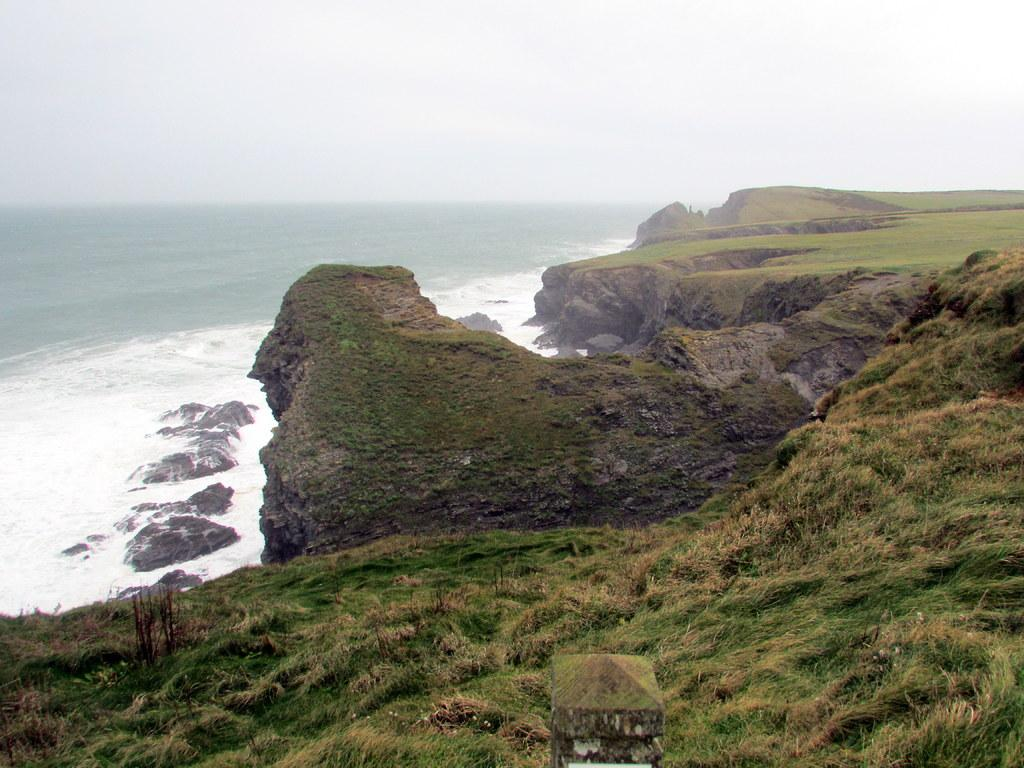What is the primary element visible in the image? There is water in the image. What other objects or features can be seen in the image? There are rocks and plants on the ground in the image. What can be seen in the background of the image? The sky is visible in the background of the image. How much payment is required to cross the blade in the image? There is no blade or payment mentioned in the image; it features water, rocks, plants, and the sky. 